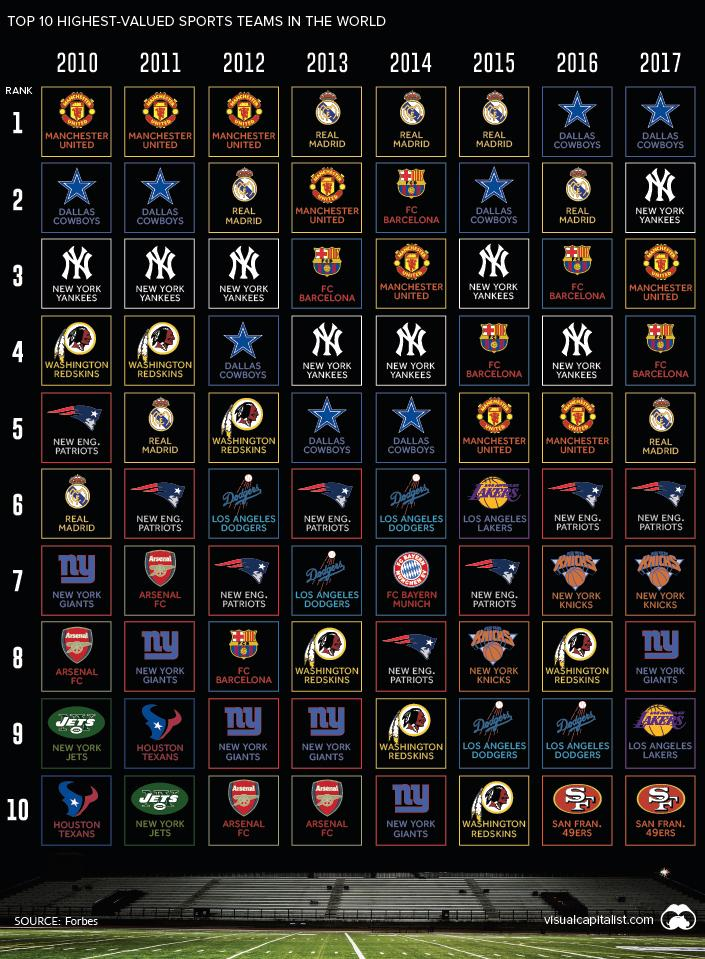List a handful of essential elements in this visual. The teams of Manchester United and Real Madrid have consistently ranked among the top teams in the world for three consecutive years. In 2015, FC Barcelona dropped from the second position to the fourth rank, marking a significant decline in their performance during that year. The Washington Redskins were placed in the fifth row in the year 2012. The lowest recorded ranking of FCB was in 2012. For two consecutive years, the Dallas Cowboys ranked as the number one team in the league. 